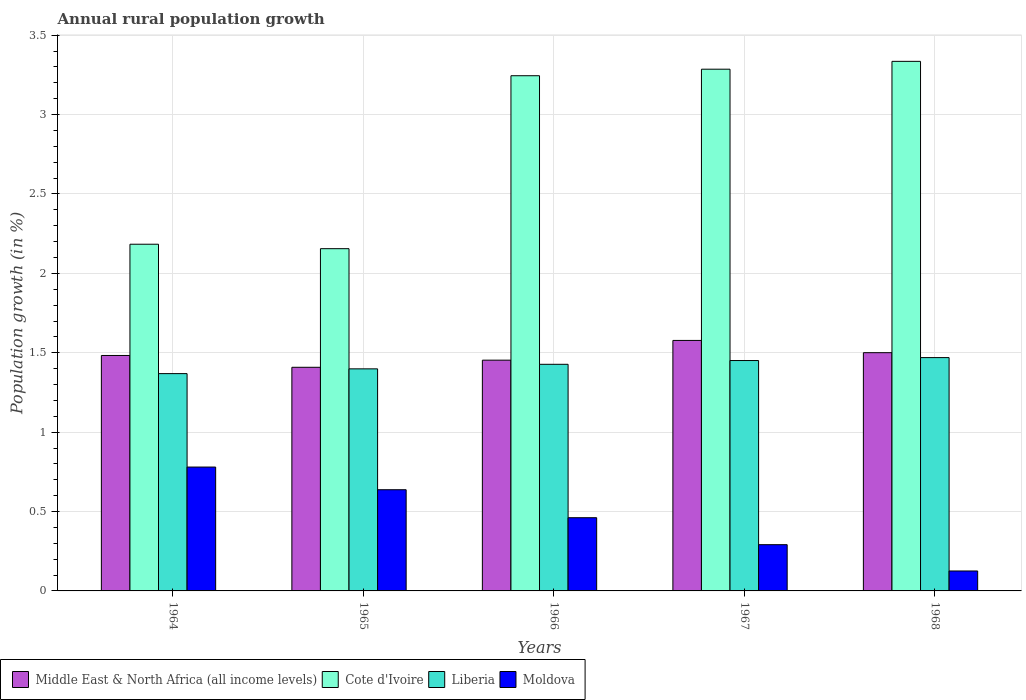How many groups of bars are there?
Offer a very short reply. 5. How many bars are there on the 5th tick from the left?
Your answer should be very brief. 4. How many bars are there on the 2nd tick from the right?
Keep it short and to the point. 4. What is the label of the 5th group of bars from the left?
Your answer should be very brief. 1968. What is the percentage of rural population growth in Cote d'Ivoire in 1967?
Your response must be concise. 3.29. Across all years, what is the maximum percentage of rural population growth in Moldova?
Your response must be concise. 0.78. Across all years, what is the minimum percentage of rural population growth in Middle East & North Africa (all income levels)?
Give a very brief answer. 1.41. In which year was the percentage of rural population growth in Cote d'Ivoire maximum?
Provide a succinct answer. 1968. In which year was the percentage of rural population growth in Moldova minimum?
Give a very brief answer. 1968. What is the total percentage of rural population growth in Moldova in the graph?
Your answer should be compact. 2.3. What is the difference between the percentage of rural population growth in Cote d'Ivoire in 1965 and that in 1967?
Your response must be concise. -1.13. What is the difference between the percentage of rural population growth in Middle East & North Africa (all income levels) in 1965 and the percentage of rural population growth in Cote d'Ivoire in 1968?
Your answer should be compact. -1.93. What is the average percentage of rural population growth in Middle East & North Africa (all income levels) per year?
Offer a very short reply. 1.48. In the year 1967, what is the difference between the percentage of rural population growth in Middle East & North Africa (all income levels) and percentage of rural population growth in Moldova?
Provide a succinct answer. 1.29. What is the ratio of the percentage of rural population growth in Liberia in 1964 to that in 1965?
Your response must be concise. 0.98. Is the percentage of rural population growth in Middle East & North Africa (all income levels) in 1966 less than that in 1967?
Offer a very short reply. Yes. What is the difference between the highest and the second highest percentage of rural population growth in Cote d'Ivoire?
Provide a succinct answer. 0.05. What is the difference between the highest and the lowest percentage of rural population growth in Middle East & North Africa (all income levels)?
Your answer should be compact. 0.17. Is it the case that in every year, the sum of the percentage of rural population growth in Cote d'Ivoire and percentage of rural population growth in Liberia is greater than the sum of percentage of rural population growth in Moldova and percentage of rural population growth in Middle East & North Africa (all income levels)?
Give a very brief answer. Yes. What does the 3rd bar from the left in 1965 represents?
Your answer should be very brief. Liberia. What does the 4th bar from the right in 1965 represents?
Provide a short and direct response. Middle East & North Africa (all income levels). Is it the case that in every year, the sum of the percentage of rural population growth in Moldova and percentage of rural population growth in Cote d'Ivoire is greater than the percentage of rural population growth in Liberia?
Provide a succinct answer. Yes. Are all the bars in the graph horizontal?
Provide a succinct answer. No. What is the difference between two consecutive major ticks on the Y-axis?
Ensure brevity in your answer.  0.5. Are the values on the major ticks of Y-axis written in scientific E-notation?
Ensure brevity in your answer.  No. Does the graph contain any zero values?
Your answer should be very brief. No. Does the graph contain grids?
Provide a short and direct response. Yes. Where does the legend appear in the graph?
Your answer should be very brief. Bottom left. What is the title of the graph?
Offer a very short reply. Annual rural population growth. What is the label or title of the Y-axis?
Keep it short and to the point. Population growth (in %). What is the Population growth (in %) of Middle East & North Africa (all income levels) in 1964?
Your answer should be very brief. 1.48. What is the Population growth (in %) of Cote d'Ivoire in 1964?
Your response must be concise. 2.18. What is the Population growth (in %) of Liberia in 1964?
Ensure brevity in your answer.  1.37. What is the Population growth (in %) of Moldova in 1964?
Give a very brief answer. 0.78. What is the Population growth (in %) in Middle East & North Africa (all income levels) in 1965?
Your response must be concise. 1.41. What is the Population growth (in %) of Cote d'Ivoire in 1965?
Provide a succinct answer. 2.16. What is the Population growth (in %) of Liberia in 1965?
Your answer should be compact. 1.4. What is the Population growth (in %) in Moldova in 1965?
Provide a succinct answer. 0.64. What is the Population growth (in %) in Middle East & North Africa (all income levels) in 1966?
Make the answer very short. 1.45. What is the Population growth (in %) in Cote d'Ivoire in 1966?
Your answer should be very brief. 3.24. What is the Population growth (in %) in Liberia in 1966?
Offer a very short reply. 1.43. What is the Population growth (in %) of Moldova in 1966?
Keep it short and to the point. 0.46. What is the Population growth (in %) in Middle East & North Africa (all income levels) in 1967?
Keep it short and to the point. 1.58. What is the Population growth (in %) in Cote d'Ivoire in 1967?
Your answer should be compact. 3.29. What is the Population growth (in %) in Liberia in 1967?
Offer a very short reply. 1.45. What is the Population growth (in %) in Moldova in 1967?
Give a very brief answer. 0.29. What is the Population growth (in %) in Middle East & North Africa (all income levels) in 1968?
Offer a very short reply. 1.5. What is the Population growth (in %) in Cote d'Ivoire in 1968?
Ensure brevity in your answer.  3.34. What is the Population growth (in %) of Liberia in 1968?
Ensure brevity in your answer.  1.47. What is the Population growth (in %) in Moldova in 1968?
Give a very brief answer. 0.13. Across all years, what is the maximum Population growth (in %) in Middle East & North Africa (all income levels)?
Ensure brevity in your answer.  1.58. Across all years, what is the maximum Population growth (in %) in Cote d'Ivoire?
Your answer should be compact. 3.34. Across all years, what is the maximum Population growth (in %) of Liberia?
Provide a short and direct response. 1.47. Across all years, what is the maximum Population growth (in %) of Moldova?
Make the answer very short. 0.78. Across all years, what is the minimum Population growth (in %) of Middle East & North Africa (all income levels)?
Provide a succinct answer. 1.41. Across all years, what is the minimum Population growth (in %) of Cote d'Ivoire?
Your answer should be compact. 2.16. Across all years, what is the minimum Population growth (in %) of Liberia?
Keep it short and to the point. 1.37. Across all years, what is the minimum Population growth (in %) in Moldova?
Offer a very short reply. 0.13. What is the total Population growth (in %) of Middle East & North Africa (all income levels) in the graph?
Ensure brevity in your answer.  7.42. What is the total Population growth (in %) of Cote d'Ivoire in the graph?
Give a very brief answer. 14.21. What is the total Population growth (in %) of Liberia in the graph?
Your answer should be compact. 7.12. What is the total Population growth (in %) in Moldova in the graph?
Your response must be concise. 2.3. What is the difference between the Population growth (in %) in Middle East & North Africa (all income levels) in 1964 and that in 1965?
Provide a short and direct response. 0.07. What is the difference between the Population growth (in %) in Cote d'Ivoire in 1964 and that in 1965?
Provide a succinct answer. 0.03. What is the difference between the Population growth (in %) of Liberia in 1964 and that in 1965?
Offer a very short reply. -0.03. What is the difference between the Population growth (in %) in Moldova in 1964 and that in 1965?
Your answer should be very brief. 0.14. What is the difference between the Population growth (in %) in Middle East & North Africa (all income levels) in 1964 and that in 1966?
Make the answer very short. 0.03. What is the difference between the Population growth (in %) in Cote d'Ivoire in 1964 and that in 1966?
Keep it short and to the point. -1.06. What is the difference between the Population growth (in %) in Liberia in 1964 and that in 1966?
Make the answer very short. -0.06. What is the difference between the Population growth (in %) in Moldova in 1964 and that in 1966?
Provide a succinct answer. 0.32. What is the difference between the Population growth (in %) of Middle East & North Africa (all income levels) in 1964 and that in 1967?
Provide a succinct answer. -0.09. What is the difference between the Population growth (in %) of Cote d'Ivoire in 1964 and that in 1967?
Your answer should be very brief. -1.1. What is the difference between the Population growth (in %) in Liberia in 1964 and that in 1967?
Give a very brief answer. -0.08. What is the difference between the Population growth (in %) in Moldova in 1964 and that in 1967?
Ensure brevity in your answer.  0.49. What is the difference between the Population growth (in %) in Middle East & North Africa (all income levels) in 1964 and that in 1968?
Provide a succinct answer. -0.02. What is the difference between the Population growth (in %) in Cote d'Ivoire in 1964 and that in 1968?
Offer a very short reply. -1.15. What is the difference between the Population growth (in %) in Liberia in 1964 and that in 1968?
Give a very brief answer. -0.1. What is the difference between the Population growth (in %) of Moldova in 1964 and that in 1968?
Offer a very short reply. 0.65. What is the difference between the Population growth (in %) in Middle East & North Africa (all income levels) in 1965 and that in 1966?
Offer a very short reply. -0.04. What is the difference between the Population growth (in %) in Cote d'Ivoire in 1965 and that in 1966?
Keep it short and to the point. -1.09. What is the difference between the Population growth (in %) in Liberia in 1965 and that in 1966?
Make the answer very short. -0.03. What is the difference between the Population growth (in %) of Moldova in 1965 and that in 1966?
Keep it short and to the point. 0.18. What is the difference between the Population growth (in %) of Middle East & North Africa (all income levels) in 1965 and that in 1967?
Keep it short and to the point. -0.17. What is the difference between the Population growth (in %) in Cote d'Ivoire in 1965 and that in 1967?
Keep it short and to the point. -1.13. What is the difference between the Population growth (in %) in Liberia in 1965 and that in 1967?
Keep it short and to the point. -0.05. What is the difference between the Population growth (in %) of Moldova in 1965 and that in 1967?
Your answer should be very brief. 0.35. What is the difference between the Population growth (in %) of Middle East & North Africa (all income levels) in 1965 and that in 1968?
Make the answer very short. -0.09. What is the difference between the Population growth (in %) of Cote d'Ivoire in 1965 and that in 1968?
Your answer should be very brief. -1.18. What is the difference between the Population growth (in %) of Liberia in 1965 and that in 1968?
Your response must be concise. -0.07. What is the difference between the Population growth (in %) in Moldova in 1965 and that in 1968?
Provide a short and direct response. 0.51. What is the difference between the Population growth (in %) in Middle East & North Africa (all income levels) in 1966 and that in 1967?
Make the answer very short. -0.12. What is the difference between the Population growth (in %) in Cote d'Ivoire in 1966 and that in 1967?
Provide a succinct answer. -0.04. What is the difference between the Population growth (in %) of Liberia in 1966 and that in 1967?
Ensure brevity in your answer.  -0.02. What is the difference between the Population growth (in %) of Moldova in 1966 and that in 1967?
Keep it short and to the point. 0.17. What is the difference between the Population growth (in %) of Middle East & North Africa (all income levels) in 1966 and that in 1968?
Your response must be concise. -0.05. What is the difference between the Population growth (in %) of Cote d'Ivoire in 1966 and that in 1968?
Offer a very short reply. -0.09. What is the difference between the Population growth (in %) of Liberia in 1966 and that in 1968?
Make the answer very short. -0.04. What is the difference between the Population growth (in %) of Moldova in 1966 and that in 1968?
Make the answer very short. 0.34. What is the difference between the Population growth (in %) in Middle East & North Africa (all income levels) in 1967 and that in 1968?
Offer a very short reply. 0.08. What is the difference between the Population growth (in %) in Cote d'Ivoire in 1967 and that in 1968?
Make the answer very short. -0.05. What is the difference between the Population growth (in %) of Liberia in 1967 and that in 1968?
Keep it short and to the point. -0.02. What is the difference between the Population growth (in %) of Moldova in 1967 and that in 1968?
Ensure brevity in your answer.  0.17. What is the difference between the Population growth (in %) in Middle East & North Africa (all income levels) in 1964 and the Population growth (in %) in Cote d'Ivoire in 1965?
Offer a terse response. -0.67. What is the difference between the Population growth (in %) in Middle East & North Africa (all income levels) in 1964 and the Population growth (in %) in Liberia in 1965?
Your response must be concise. 0.08. What is the difference between the Population growth (in %) of Middle East & North Africa (all income levels) in 1964 and the Population growth (in %) of Moldova in 1965?
Provide a short and direct response. 0.85. What is the difference between the Population growth (in %) of Cote d'Ivoire in 1964 and the Population growth (in %) of Liberia in 1965?
Your answer should be very brief. 0.78. What is the difference between the Population growth (in %) in Cote d'Ivoire in 1964 and the Population growth (in %) in Moldova in 1965?
Keep it short and to the point. 1.55. What is the difference between the Population growth (in %) in Liberia in 1964 and the Population growth (in %) in Moldova in 1965?
Provide a succinct answer. 0.73. What is the difference between the Population growth (in %) in Middle East & North Africa (all income levels) in 1964 and the Population growth (in %) in Cote d'Ivoire in 1966?
Your answer should be compact. -1.76. What is the difference between the Population growth (in %) of Middle East & North Africa (all income levels) in 1964 and the Population growth (in %) of Liberia in 1966?
Your answer should be very brief. 0.06. What is the difference between the Population growth (in %) of Middle East & North Africa (all income levels) in 1964 and the Population growth (in %) of Moldova in 1966?
Your answer should be compact. 1.02. What is the difference between the Population growth (in %) of Cote d'Ivoire in 1964 and the Population growth (in %) of Liberia in 1966?
Offer a very short reply. 0.76. What is the difference between the Population growth (in %) in Cote d'Ivoire in 1964 and the Population growth (in %) in Moldova in 1966?
Provide a succinct answer. 1.72. What is the difference between the Population growth (in %) of Liberia in 1964 and the Population growth (in %) of Moldova in 1966?
Ensure brevity in your answer.  0.91. What is the difference between the Population growth (in %) of Middle East & North Africa (all income levels) in 1964 and the Population growth (in %) of Cote d'Ivoire in 1967?
Make the answer very short. -1.8. What is the difference between the Population growth (in %) in Middle East & North Africa (all income levels) in 1964 and the Population growth (in %) in Liberia in 1967?
Give a very brief answer. 0.03. What is the difference between the Population growth (in %) of Middle East & North Africa (all income levels) in 1964 and the Population growth (in %) of Moldova in 1967?
Offer a terse response. 1.19. What is the difference between the Population growth (in %) of Cote d'Ivoire in 1964 and the Population growth (in %) of Liberia in 1967?
Offer a terse response. 0.73. What is the difference between the Population growth (in %) of Cote d'Ivoire in 1964 and the Population growth (in %) of Moldova in 1967?
Provide a short and direct response. 1.89. What is the difference between the Population growth (in %) in Liberia in 1964 and the Population growth (in %) in Moldova in 1967?
Ensure brevity in your answer.  1.08. What is the difference between the Population growth (in %) of Middle East & North Africa (all income levels) in 1964 and the Population growth (in %) of Cote d'Ivoire in 1968?
Offer a very short reply. -1.85. What is the difference between the Population growth (in %) in Middle East & North Africa (all income levels) in 1964 and the Population growth (in %) in Liberia in 1968?
Ensure brevity in your answer.  0.01. What is the difference between the Population growth (in %) in Middle East & North Africa (all income levels) in 1964 and the Population growth (in %) in Moldova in 1968?
Your answer should be very brief. 1.36. What is the difference between the Population growth (in %) in Cote d'Ivoire in 1964 and the Population growth (in %) in Liberia in 1968?
Make the answer very short. 0.71. What is the difference between the Population growth (in %) in Cote d'Ivoire in 1964 and the Population growth (in %) in Moldova in 1968?
Your answer should be very brief. 2.06. What is the difference between the Population growth (in %) in Liberia in 1964 and the Population growth (in %) in Moldova in 1968?
Give a very brief answer. 1.24. What is the difference between the Population growth (in %) in Middle East & North Africa (all income levels) in 1965 and the Population growth (in %) in Cote d'Ivoire in 1966?
Provide a short and direct response. -1.84. What is the difference between the Population growth (in %) of Middle East & North Africa (all income levels) in 1965 and the Population growth (in %) of Liberia in 1966?
Ensure brevity in your answer.  -0.02. What is the difference between the Population growth (in %) of Middle East & North Africa (all income levels) in 1965 and the Population growth (in %) of Moldova in 1966?
Ensure brevity in your answer.  0.95. What is the difference between the Population growth (in %) of Cote d'Ivoire in 1965 and the Population growth (in %) of Liberia in 1966?
Offer a terse response. 0.73. What is the difference between the Population growth (in %) of Cote d'Ivoire in 1965 and the Population growth (in %) of Moldova in 1966?
Your response must be concise. 1.69. What is the difference between the Population growth (in %) in Middle East & North Africa (all income levels) in 1965 and the Population growth (in %) in Cote d'Ivoire in 1967?
Your answer should be very brief. -1.88. What is the difference between the Population growth (in %) of Middle East & North Africa (all income levels) in 1965 and the Population growth (in %) of Liberia in 1967?
Your answer should be very brief. -0.04. What is the difference between the Population growth (in %) in Middle East & North Africa (all income levels) in 1965 and the Population growth (in %) in Moldova in 1967?
Provide a succinct answer. 1.12. What is the difference between the Population growth (in %) in Cote d'Ivoire in 1965 and the Population growth (in %) in Liberia in 1967?
Keep it short and to the point. 0.7. What is the difference between the Population growth (in %) of Cote d'Ivoire in 1965 and the Population growth (in %) of Moldova in 1967?
Your answer should be compact. 1.86. What is the difference between the Population growth (in %) in Liberia in 1965 and the Population growth (in %) in Moldova in 1967?
Your answer should be compact. 1.11. What is the difference between the Population growth (in %) in Middle East & North Africa (all income levels) in 1965 and the Population growth (in %) in Cote d'Ivoire in 1968?
Keep it short and to the point. -1.93. What is the difference between the Population growth (in %) in Middle East & North Africa (all income levels) in 1965 and the Population growth (in %) in Liberia in 1968?
Provide a succinct answer. -0.06. What is the difference between the Population growth (in %) of Middle East & North Africa (all income levels) in 1965 and the Population growth (in %) of Moldova in 1968?
Your response must be concise. 1.28. What is the difference between the Population growth (in %) of Cote d'Ivoire in 1965 and the Population growth (in %) of Liberia in 1968?
Offer a terse response. 0.69. What is the difference between the Population growth (in %) in Cote d'Ivoire in 1965 and the Population growth (in %) in Moldova in 1968?
Your answer should be very brief. 2.03. What is the difference between the Population growth (in %) of Liberia in 1965 and the Population growth (in %) of Moldova in 1968?
Your answer should be very brief. 1.27. What is the difference between the Population growth (in %) of Middle East & North Africa (all income levels) in 1966 and the Population growth (in %) of Cote d'Ivoire in 1967?
Keep it short and to the point. -1.83. What is the difference between the Population growth (in %) in Middle East & North Africa (all income levels) in 1966 and the Population growth (in %) in Liberia in 1967?
Make the answer very short. 0. What is the difference between the Population growth (in %) in Middle East & North Africa (all income levels) in 1966 and the Population growth (in %) in Moldova in 1967?
Your answer should be very brief. 1.16. What is the difference between the Population growth (in %) in Cote d'Ivoire in 1966 and the Population growth (in %) in Liberia in 1967?
Offer a terse response. 1.79. What is the difference between the Population growth (in %) in Cote d'Ivoire in 1966 and the Population growth (in %) in Moldova in 1967?
Offer a terse response. 2.95. What is the difference between the Population growth (in %) in Liberia in 1966 and the Population growth (in %) in Moldova in 1967?
Provide a short and direct response. 1.14. What is the difference between the Population growth (in %) in Middle East & North Africa (all income levels) in 1966 and the Population growth (in %) in Cote d'Ivoire in 1968?
Ensure brevity in your answer.  -1.88. What is the difference between the Population growth (in %) of Middle East & North Africa (all income levels) in 1966 and the Population growth (in %) of Liberia in 1968?
Your response must be concise. -0.02. What is the difference between the Population growth (in %) of Middle East & North Africa (all income levels) in 1966 and the Population growth (in %) of Moldova in 1968?
Your response must be concise. 1.33. What is the difference between the Population growth (in %) of Cote d'Ivoire in 1966 and the Population growth (in %) of Liberia in 1968?
Give a very brief answer. 1.78. What is the difference between the Population growth (in %) of Cote d'Ivoire in 1966 and the Population growth (in %) of Moldova in 1968?
Offer a terse response. 3.12. What is the difference between the Population growth (in %) of Liberia in 1966 and the Population growth (in %) of Moldova in 1968?
Your answer should be compact. 1.3. What is the difference between the Population growth (in %) of Middle East & North Africa (all income levels) in 1967 and the Population growth (in %) of Cote d'Ivoire in 1968?
Give a very brief answer. -1.76. What is the difference between the Population growth (in %) in Middle East & North Africa (all income levels) in 1967 and the Population growth (in %) in Liberia in 1968?
Your answer should be very brief. 0.11. What is the difference between the Population growth (in %) of Middle East & North Africa (all income levels) in 1967 and the Population growth (in %) of Moldova in 1968?
Your answer should be compact. 1.45. What is the difference between the Population growth (in %) in Cote d'Ivoire in 1967 and the Population growth (in %) in Liberia in 1968?
Your response must be concise. 1.82. What is the difference between the Population growth (in %) of Cote d'Ivoire in 1967 and the Population growth (in %) of Moldova in 1968?
Ensure brevity in your answer.  3.16. What is the difference between the Population growth (in %) of Liberia in 1967 and the Population growth (in %) of Moldova in 1968?
Give a very brief answer. 1.33. What is the average Population growth (in %) in Middle East & North Africa (all income levels) per year?
Ensure brevity in your answer.  1.48. What is the average Population growth (in %) in Cote d'Ivoire per year?
Provide a succinct answer. 2.84. What is the average Population growth (in %) in Liberia per year?
Make the answer very short. 1.42. What is the average Population growth (in %) of Moldova per year?
Your answer should be very brief. 0.46. In the year 1964, what is the difference between the Population growth (in %) in Middle East & North Africa (all income levels) and Population growth (in %) in Cote d'Ivoire?
Ensure brevity in your answer.  -0.7. In the year 1964, what is the difference between the Population growth (in %) of Middle East & North Africa (all income levels) and Population growth (in %) of Liberia?
Ensure brevity in your answer.  0.11. In the year 1964, what is the difference between the Population growth (in %) in Middle East & North Africa (all income levels) and Population growth (in %) in Moldova?
Offer a terse response. 0.7. In the year 1964, what is the difference between the Population growth (in %) in Cote d'Ivoire and Population growth (in %) in Liberia?
Your response must be concise. 0.81. In the year 1964, what is the difference between the Population growth (in %) of Cote d'Ivoire and Population growth (in %) of Moldova?
Give a very brief answer. 1.4. In the year 1964, what is the difference between the Population growth (in %) in Liberia and Population growth (in %) in Moldova?
Make the answer very short. 0.59. In the year 1965, what is the difference between the Population growth (in %) of Middle East & North Africa (all income levels) and Population growth (in %) of Cote d'Ivoire?
Your response must be concise. -0.75. In the year 1965, what is the difference between the Population growth (in %) of Middle East & North Africa (all income levels) and Population growth (in %) of Liberia?
Your answer should be compact. 0.01. In the year 1965, what is the difference between the Population growth (in %) in Middle East & North Africa (all income levels) and Population growth (in %) in Moldova?
Your response must be concise. 0.77. In the year 1965, what is the difference between the Population growth (in %) in Cote d'Ivoire and Population growth (in %) in Liberia?
Provide a short and direct response. 0.76. In the year 1965, what is the difference between the Population growth (in %) in Cote d'Ivoire and Population growth (in %) in Moldova?
Provide a short and direct response. 1.52. In the year 1965, what is the difference between the Population growth (in %) of Liberia and Population growth (in %) of Moldova?
Give a very brief answer. 0.76. In the year 1966, what is the difference between the Population growth (in %) in Middle East & North Africa (all income levels) and Population growth (in %) in Cote d'Ivoire?
Your response must be concise. -1.79. In the year 1966, what is the difference between the Population growth (in %) in Middle East & North Africa (all income levels) and Population growth (in %) in Liberia?
Provide a succinct answer. 0.03. In the year 1966, what is the difference between the Population growth (in %) in Middle East & North Africa (all income levels) and Population growth (in %) in Moldova?
Provide a succinct answer. 0.99. In the year 1966, what is the difference between the Population growth (in %) in Cote d'Ivoire and Population growth (in %) in Liberia?
Your answer should be compact. 1.82. In the year 1966, what is the difference between the Population growth (in %) of Cote d'Ivoire and Population growth (in %) of Moldova?
Your response must be concise. 2.78. In the year 1966, what is the difference between the Population growth (in %) of Liberia and Population growth (in %) of Moldova?
Your answer should be very brief. 0.97. In the year 1967, what is the difference between the Population growth (in %) of Middle East & North Africa (all income levels) and Population growth (in %) of Cote d'Ivoire?
Make the answer very short. -1.71. In the year 1967, what is the difference between the Population growth (in %) of Middle East & North Africa (all income levels) and Population growth (in %) of Liberia?
Provide a succinct answer. 0.13. In the year 1967, what is the difference between the Population growth (in %) of Middle East & North Africa (all income levels) and Population growth (in %) of Moldova?
Make the answer very short. 1.29. In the year 1967, what is the difference between the Population growth (in %) in Cote d'Ivoire and Population growth (in %) in Liberia?
Keep it short and to the point. 1.83. In the year 1967, what is the difference between the Population growth (in %) of Cote d'Ivoire and Population growth (in %) of Moldova?
Provide a succinct answer. 2.99. In the year 1967, what is the difference between the Population growth (in %) in Liberia and Population growth (in %) in Moldova?
Make the answer very short. 1.16. In the year 1968, what is the difference between the Population growth (in %) in Middle East & North Africa (all income levels) and Population growth (in %) in Cote d'Ivoire?
Provide a succinct answer. -1.83. In the year 1968, what is the difference between the Population growth (in %) in Middle East & North Africa (all income levels) and Population growth (in %) in Liberia?
Your answer should be very brief. 0.03. In the year 1968, what is the difference between the Population growth (in %) of Middle East & North Africa (all income levels) and Population growth (in %) of Moldova?
Give a very brief answer. 1.37. In the year 1968, what is the difference between the Population growth (in %) in Cote d'Ivoire and Population growth (in %) in Liberia?
Your answer should be very brief. 1.87. In the year 1968, what is the difference between the Population growth (in %) in Cote d'Ivoire and Population growth (in %) in Moldova?
Provide a short and direct response. 3.21. In the year 1968, what is the difference between the Population growth (in %) of Liberia and Population growth (in %) of Moldova?
Give a very brief answer. 1.34. What is the ratio of the Population growth (in %) of Middle East & North Africa (all income levels) in 1964 to that in 1965?
Provide a succinct answer. 1.05. What is the ratio of the Population growth (in %) of Liberia in 1964 to that in 1965?
Ensure brevity in your answer.  0.98. What is the ratio of the Population growth (in %) in Moldova in 1964 to that in 1965?
Provide a succinct answer. 1.22. What is the ratio of the Population growth (in %) of Middle East & North Africa (all income levels) in 1964 to that in 1966?
Ensure brevity in your answer.  1.02. What is the ratio of the Population growth (in %) in Cote d'Ivoire in 1964 to that in 1966?
Provide a succinct answer. 0.67. What is the ratio of the Population growth (in %) of Liberia in 1964 to that in 1966?
Your response must be concise. 0.96. What is the ratio of the Population growth (in %) of Moldova in 1964 to that in 1966?
Offer a very short reply. 1.69. What is the ratio of the Population growth (in %) in Middle East & North Africa (all income levels) in 1964 to that in 1967?
Offer a very short reply. 0.94. What is the ratio of the Population growth (in %) in Cote d'Ivoire in 1964 to that in 1967?
Give a very brief answer. 0.66. What is the ratio of the Population growth (in %) of Liberia in 1964 to that in 1967?
Your response must be concise. 0.94. What is the ratio of the Population growth (in %) of Moldova in 1964 to that in 1967?
Your answer should be compact. 2.68. What is the ratio of the Population growth (in %) in Middle East & North Africa (all income levels) in 1964 to that in 1968?
Offer a terse response. 0.99. What is the ratio of the Population growth (in %) in Cote d'Ivoire in 1964 to that in 1968?
Keep it short and to the point. 0.65. What is the ratio of the Population growth (in %) in Liberia in 1964 to that in 1968?
Provide a short and direct response. 0.93. What is the ratio of the Population growth (in %) of Moldova in 1964 to that in 1968?
Give a very brief answer. 6.21. What is the ratio of the Population growth (in %) in Middle East & North Africa (all income levels) in 1965 to that in 1966?
Your answer should be very brief. 0.97. What is the ratio of the Population growth (in %) of Cote d'Ivoire in 1965 to that in 1966?
Ensure brevity in your answer.  0.66. What is the ratio of the Population growth (in %) in Liberia in 1965 to that in 1966?
Provide a succinct answer. 0.98. What is the ratio of the Population growth (in %) in Moldova in 1965 to that in 1966?
Make the answer very short. 1.38. What is the ratio of the Population growth (in %) in Middle East & North Africa (all income levels) in 1965 to that in 1967?
Provide a short and direct response. 0.89. What is the ratio of the Population growth (in %) of Cote d'Ivoire in 1965 to that in 1967?
Give a very brief answer. 0.66. What is the ratio of the Population growth (in %) of Liberia in 1965 to that in 1967?
Ensure brevity in your answer.  0.96. What is the ratio of the Population growth (in %) in Moldova in 1965 to that in 1967?
Ensure brevity in your answer.  2.19. What is the ratio of the Population growth (in %) of Middle East & North Africa (all income levels) in 1965 to that in 1968?
Your answer should be compact. 0.94. What is the ratio of the Population growth (in %) of Cote d'Ivoire in 1965 to that in 1968?
Your answer should be very brief. 0.65. What is the ratio of the Population growth (in %) of Liberia in 1965 to that in 1968?
Your answer should be very brief. 0.95. What is the ratio of the Population growth (in %) of Moldova in 1965 to that in 1968?
Provide a short and direct response. 5.08. What is the ratio of the Population growth (in %) of Middle East & North Africa (all income levels) in 1966 to that in 1967?
Keep it short and to the point. 0.92. What is the ratio of the Population growth (in %) of Cote d'Ivoire in 1966 to that in 1967?
Your answer should be very brief. 0.99. What is the ratio of the Population growth (in %) of Liberia in 1966 to that in 1967?
Your response must be concise. 0.98. What is the ratio of the Population growth (in %) of Moldova in 1966 to that in 1967?
Provide a succinct answer. 1.58. What is the ratio of the Population growth (in %) of Middle East & North Africa (all income levels) in 1966 to that in 1968?
Provide a short and direct response. 0.97. What is the ratio of the Population growth (in %) of Cote d'Ivoire in 1966 to that in 1968?
Your response must be concise. 0.97. What is the ratio of the Population growth (in %) in Liberia in 1966 to that in 1968?
Your answer should be compact. 0.97. What is the ratio of the Population growth (in %) of Moldova in 1966 to that in 1968?
Provide a short and direct response. 3.67. What is the ratio of the Population growth (in %) in Middle East & North Africa (all income levels) in 1967 to that in 1968?
Keep it short and to the point. 1.05. What is the ratio of the Population growth (in %) of Cote d'Ivoire in 1967 to that in 1968?
Make the answer very short. 0.99. What is the ratio of the Population growth (in %) in Liberia in 1967 to that in 1968?
Make the answer very short. 0.99. What is the ratio of the Population growth (in %) in Moldova in 1967 to that in 1968?
Ensure brevity in your answer.  2.32. What is the difference between the highest and the second highest Population growth (in %) of Middle East & North Africa (all income levels)?
Provide a succinct answer. 0.08. What is the difference between the highest and the second highest Population growth (in %) in Cote d'Ivoire?
Your answer should be very brief. 0.05. What is the difference between the highest and the second highest Population growth (in %) of Liberia?
Offer a terse response. 0.02. What is the difference between the highest and the second highest Population growth (in %) in Moldova?
Your answer should be compact. 0.14. What is the difference between the highest and the lowest Population growth (in %) in Middle East & North Africa (all income levels)?
Keep it short and to the point. 0.17. What is the difference between the highest and the lowest Population growth (in %) of Cote d'Ivoire?
Your response must be concise. 1.18. What is the difference between the highest and the lowest Population growth (in %) in Liberia?
Offer a very short reply. 0.1. What is the difference between the highest and the lowest Population growth (in %) in Moldova?
Give a very brief answer. 0.65. 